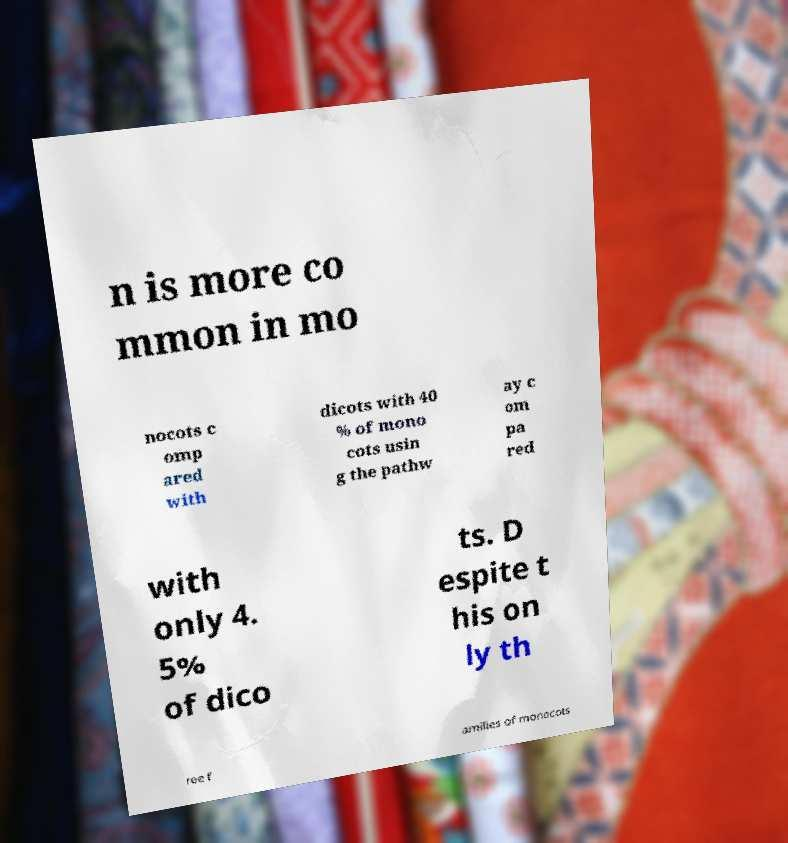Can you read and provide the text displayed in the image?This photo seems to have some interesting text. Can you extract and type it out for me? n is more co mmon in mo nocots c omp ared with dicots with 40 % of mono cots usin g the pathw ay c om pa red with only 4. 5% of dico ts. D espite t his on ly th ree f amilies of monocots 